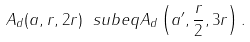<formula> <loc_0><loc_0><loc_500><loc_500>A _ { d } ( a , r , 2 r ) \ s u b e q A _ { d } \left ( a ^ { \prime } , \frac { r } { 2 } , 3 r \right ) .</formula> 